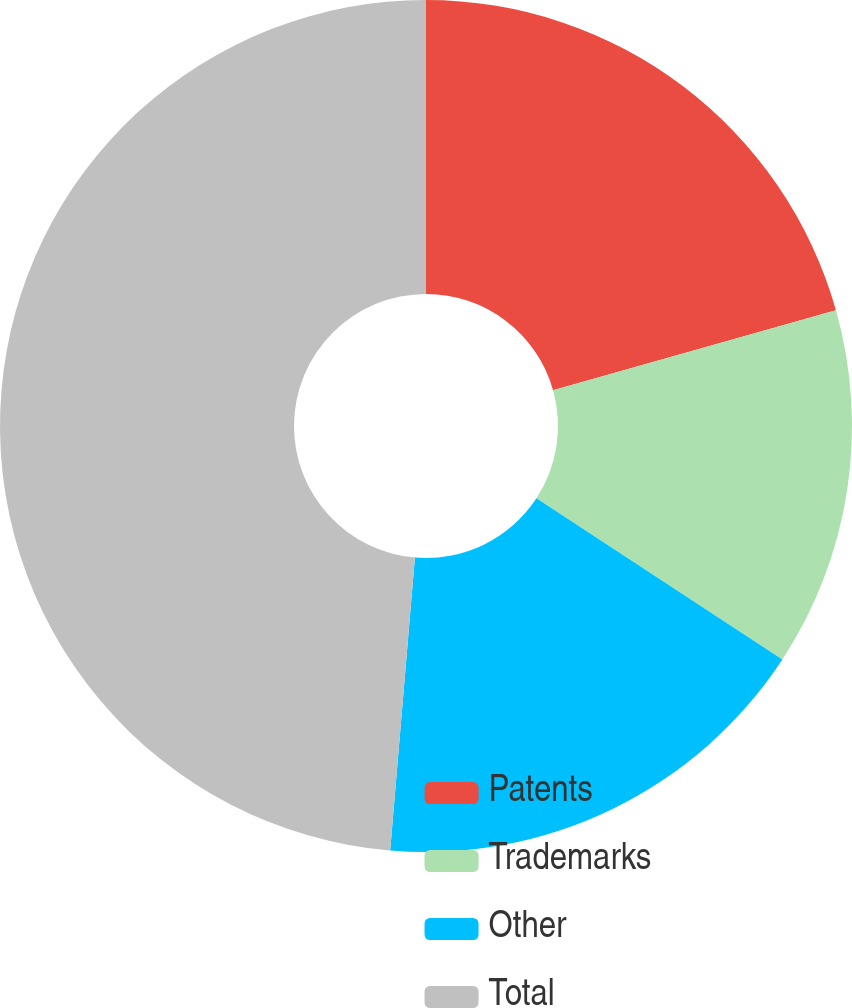Convert chart. <chart><loc_0><loc_0><loc_500><loc_500><pie_chart><fcel>Patents<fcel>Trademarks<fcel>Other<fcel>Total<nl><fcel>20.62%<fcel>13.61%<fcel>17.11%<fcel>48.66%<nl></chart> 